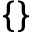Convert formula to latex. <formula><loc_0><loc_0><loc_500><loc_500>\{ \}</formula> 